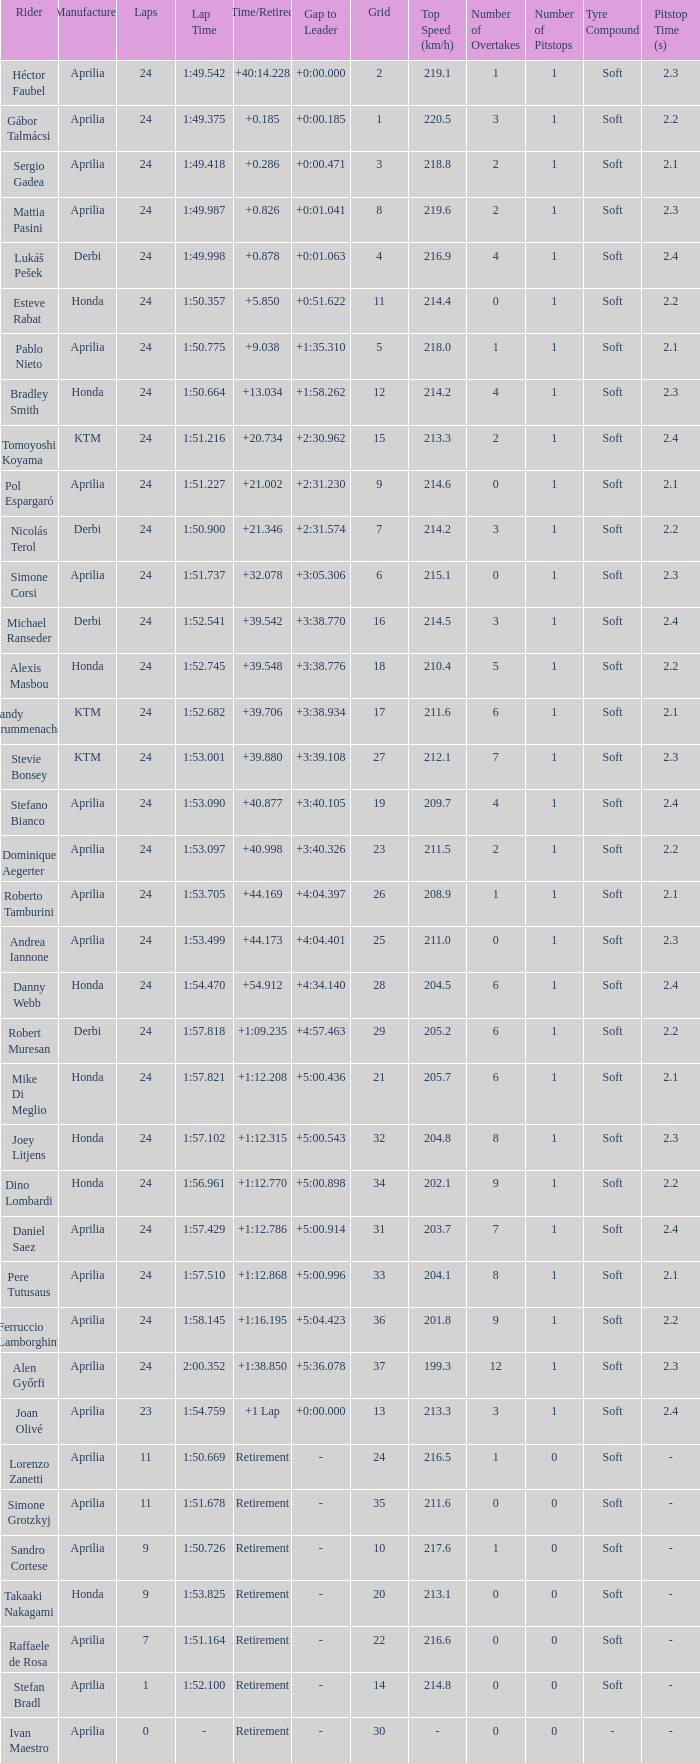Who manufactured the motorcycle that did 24 laps and 9 grids? Aprilia. 